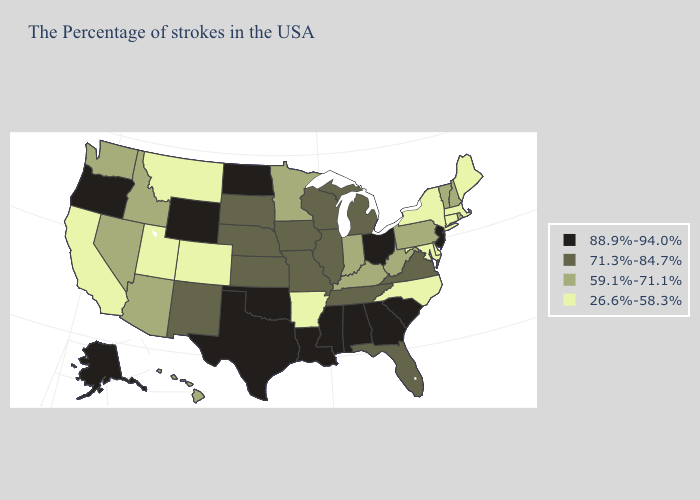Name the states that have a value in the range 26.6%-58.3%?
Concise answer only. Maine, Massachusetts, Connecticut, New York, Delaware, Maryland, North Carolina, Arkansas, Colorado, Utah, Montana, California. Name the states that have a value in the range 88.9%-94.0%?
Quick response, please. New Jersey, South Carolina, Ohio, Georgia, Alabama, Mississippi, Louisiana, Oklahoma, Texas, North Dakota, Wyoming, Oregon, Alaska. Name the states that have a value in the range 71.3%-84.7%?
Give a very brief answer. Virginia, Florida, Michigan, Tennessee, Wisconsin, Illinois, Missouri, Iowa, Kansas, Nebraska, South Dakota, New Mexico. Among the states that border Nevada , which have the lowest value?
Keep it brief. Utah, California. Name the states that have a value in the range 59.1%-71.1%?
Be succinct. Rhode Island, New Hampshire, Vermont, Pennsylvania, West Virginia, Kentucky, Indiana, Minnesota, Arizona, Idaho, Nevada, Washington, Hawaii. What is the value of Minnesota?
Concise answer only. 59.1%-71.1%. What is the value of Alaska?
Concise answer only. 88.9%-94.0%. Does Minnesota have a higher value than New Hampshire?
Be succinct. No. Among the states that border Missouri , does Arkansas have the lowest value?
Be succinct. Yes. Among the states that border California , which have the highest value?
Give a very brief answer. Oregon. What is the highest value in the West ?
Quick response, please. 88.9%-94.0%. Among the states that border Wisconsin , does Illinois have the highest value?
Keep it brief. Yes. Does Maine have the same value as Oregon?
Concise answer only. No. Does Delaware have the highest value in the USA?
Keep it brief. No. Does Oregon have a higher value than Pennsylvania?
Concise answer only. Yes. 